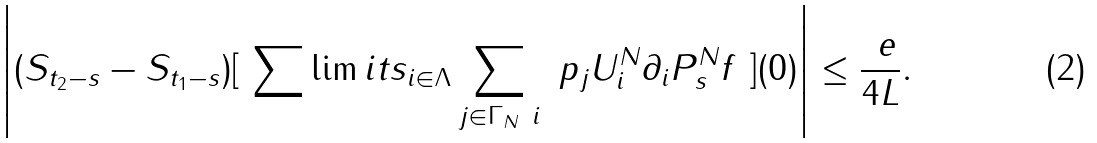Convert formula to latex. <formula><loc_0><loc_0><loc_500><loc_500>\left | ( S _ { t _ { 2 } - s } - S _ { t _ { 1 } - s } ) [ \ \sum \lim i t s _ { i \in \Lambda } \sum _ { j \in \Gamma _ { N } \ i } \ p _ { j } U _ { i } ^ { N } \partial _ { i } P ^ { N } _ { s } f \ ] ( 0 ) \right | \leq \frac { \ e } { 4 L } .</formula> 